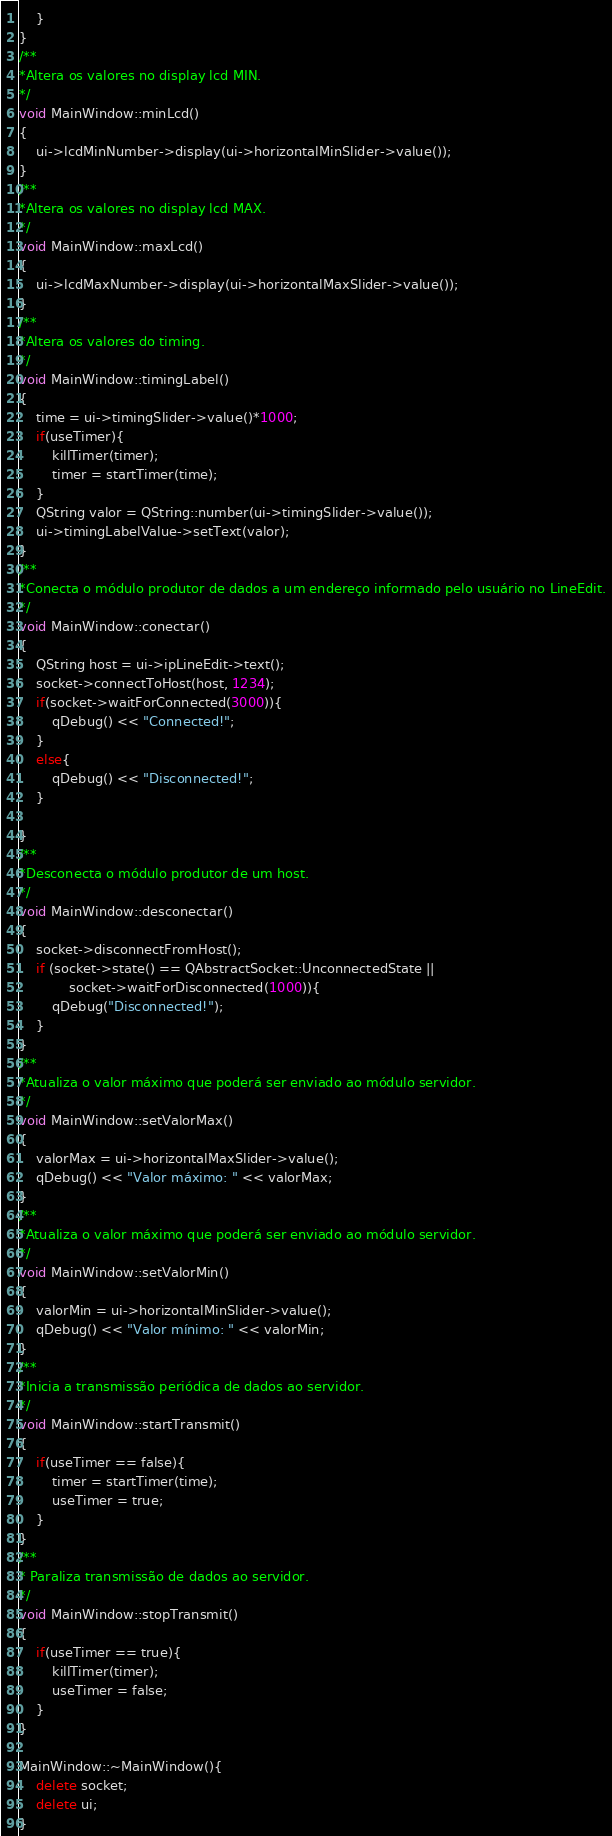Convert code to text. <code><loc_0><loc_0><loc_500><loc_500><_C++_>    }
}
/**
*Altera os valores no display lcd MIN.
*/
void MainWindow::minLcd()
{
    ui->lcdMinNumber->display(ui->horizontalMinSlider->value());
}
/**
*Altera os valores no display lcd MAX.
*/
void MainWindow::maxLcd()
{
    ui->lcdMaxNumber->display(ui->horizontalMaxSlider->value());
}
/**
*Altera os valores do timing.
*/
void MainWindow::timingLabel()
{
    time = ui->timingSlider->value()*1000;
    if(useTimer){
        killTimer(timer);
        timer = startTimer(time);
    }
    QString valor = QString::number(ui->timingSlider->value());
    ui->timingLabelValue->setText(valor);
}
/**
*Conecta o módulo produtor de dados a um endereço informado pelo usuário no LineEdit.
*/
void MainWindow::conectar()
{
    QString host = ui->ipLineEdit->text();
    socket->connectToHost(host, 1234);
    if(socket->waitForConnected(3000)){
        qDebug() << "Connected!";
    }
    else{
        qDebug() << "Disconnected!";
    }

}
/**
*Desconecta o módulo produtor de um host.
*/
void MainWindow::desconectar()
{
    socket->disconnectFromHost();
    if (socket->state() == QAbstractSocket::UnconnectedState ||
            socket->waitForDisconnected(1000)){
        qDebug("Disconnected!");
    }
}
/**
*Atualiza o valor máximo que poderá ser enviado ao módulo servidor.
*/
void MainWindow::setValorMax()
{
    valorMax = ui->horizontalMaxSlider->value();
    qDebug() << "Valor máximo: " << valorMax;
}
/**
*Atualiza o valor máximo que poderá ser enviado ao módulo servidor.
*/
void MainWindow::setValorMin()
{
    valorMin = ui->horizontalMinSlider->value();
    qDebug() << "Valor mínimo: " << valorMin;
}
/**
*Inicia a transmissão periódica de dados ao servidor.
*/
void MainWindow::startTransmit()
{
    if(useTimer == false){
        timer = startTimer(time);
        useTimer = true;
    }
}
/**
* Paraliza transmissão de dados ao servidor.
*/
void MainWindow::stopTransmit()
{
    if(useTimer == true){
        killTimer(timer);
        useTimer = false;
    }
}

MainWindow::~MainWindow(){
    delete socket;
    delete ui;
}
</code> 